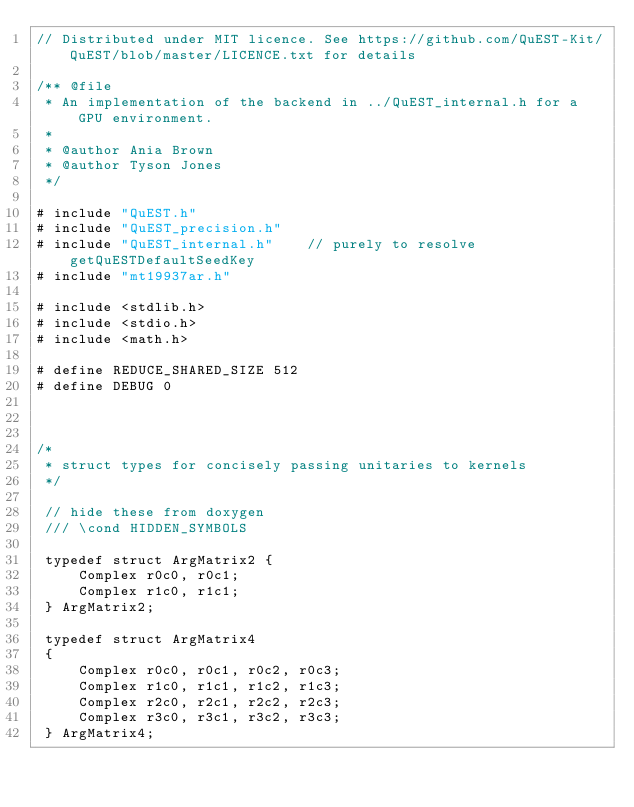<code> <loc_0><loc_0><loc_500><loc_500><_Cuda_>// Distributed under MIT licence. See https://github.com/QuEST-Kit/QuEST/blob/master/LICENCE.txt for details

/** @file
 * An implementation of the backend in ../QuEST_internal.h for a GPU environment.
 *
 * @author Ania Brown 
 * @author Tyson Jones
 */

# include "QuEST.h"
# include "QuEST_precision.h"
# include "QuEST_internal.h"    // purely to resolve getQuESTDefaultSeedKey
# include "mt19937ar.h"

# include <stdlib.h>
# include <stdio.h>
# include <math.h>

# define REDUCE_SHARED_SIZE 512
# define DEBUG 0



/*
 * struct types for concisely passing unitaries to kernels
 */
 
 // hide these from doxygen
 /// \cond HIDDEN_SYMBOLS  
 
 typedef struct ArgMatrix2 {
     Complex r0c0, r0c1;
     Complex r1c0, r1c1;
 } ArgMatrix2;
 
 typedef struct ArgMatrix4
 {
     Complex r0c0, r0c1, r0c2, r0c3;
     Complex r1c0, r1c1, r1c2, r1c3;
     Complex r2c0, r2c1, r2c2, r2c3;
     Complex r3c0, r3c1, r3c2, r3c3;
 } ArgMatrix4;
 </code> 